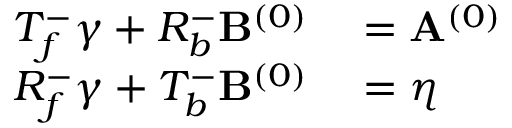Convert formula to latex. <formula><loc_0><loc_0><loc_500><loc_500>\begin{array} { r l } { T _ { f } ^ { - } \gamma + R _ { b } ^ { - } B ^ { ( 0 ) } } & = A ^ { ( 0 ) } } \\ { R _ { f } ^ { - } \gamma + T _ { b } ^ { - } B ^ { ( 0 ) } } & = \eta } \end{array}</formula> 